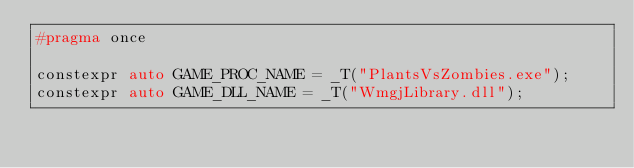<code> <loc_0><loc_0><loc_500><loc_500><_C_>#pragma once

constexpr auto GAME_PROC_NAME = _T("PlantsVsZombies.exe");
constexpr auto GAME_DLL_NAME = _T("WmgjLibrary.dll");
</code> 